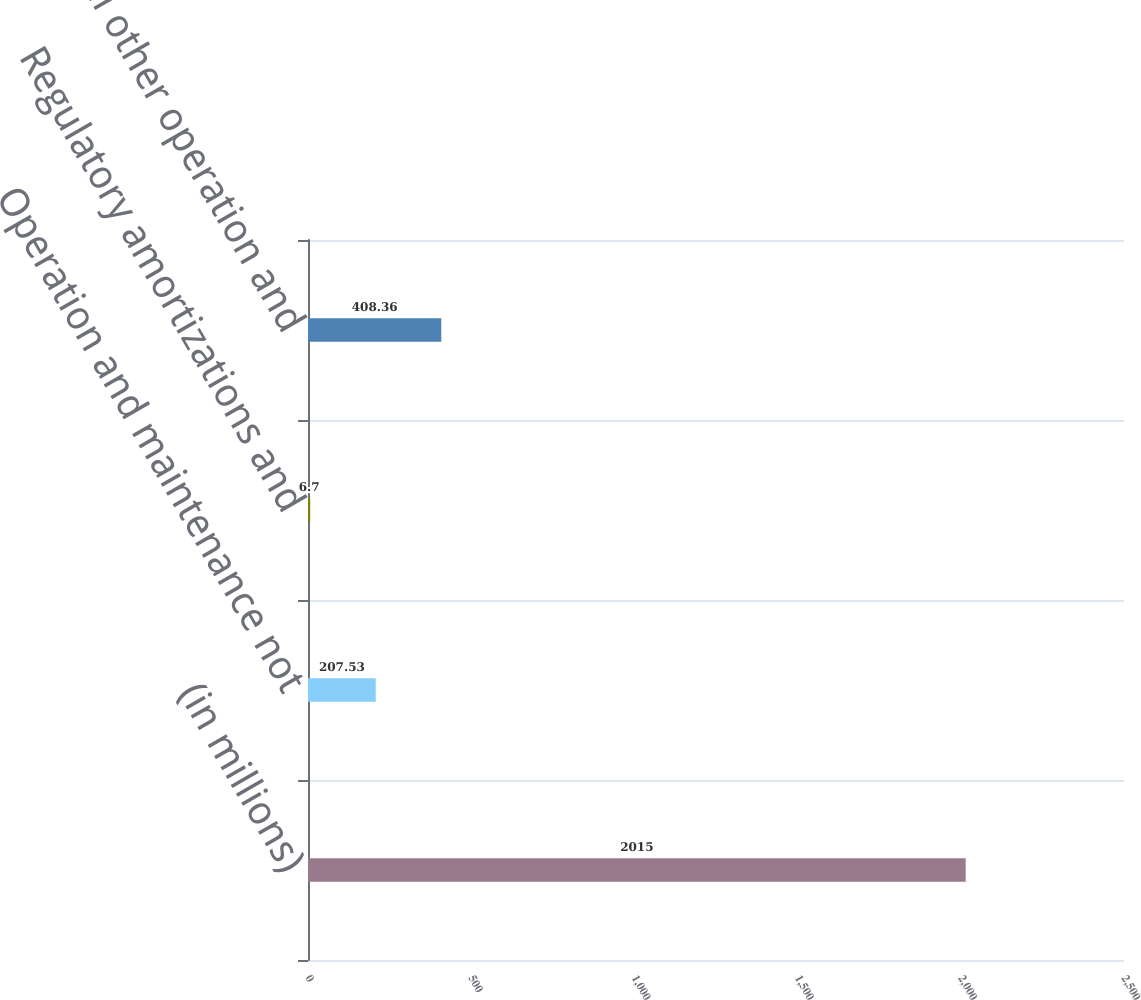Convert chart to OTSL. <chart><loc_0><loc_0><loc_500><loc_500><bar_chart><fcel>(in millions)<fcel>Operation and maintenance not<fcel>Regulatory amortizations and<fcel>Total other operation and<nl><fcel>2015<fcel>207.53<fcel>6.7<fcel>408.36<nl></chart> 